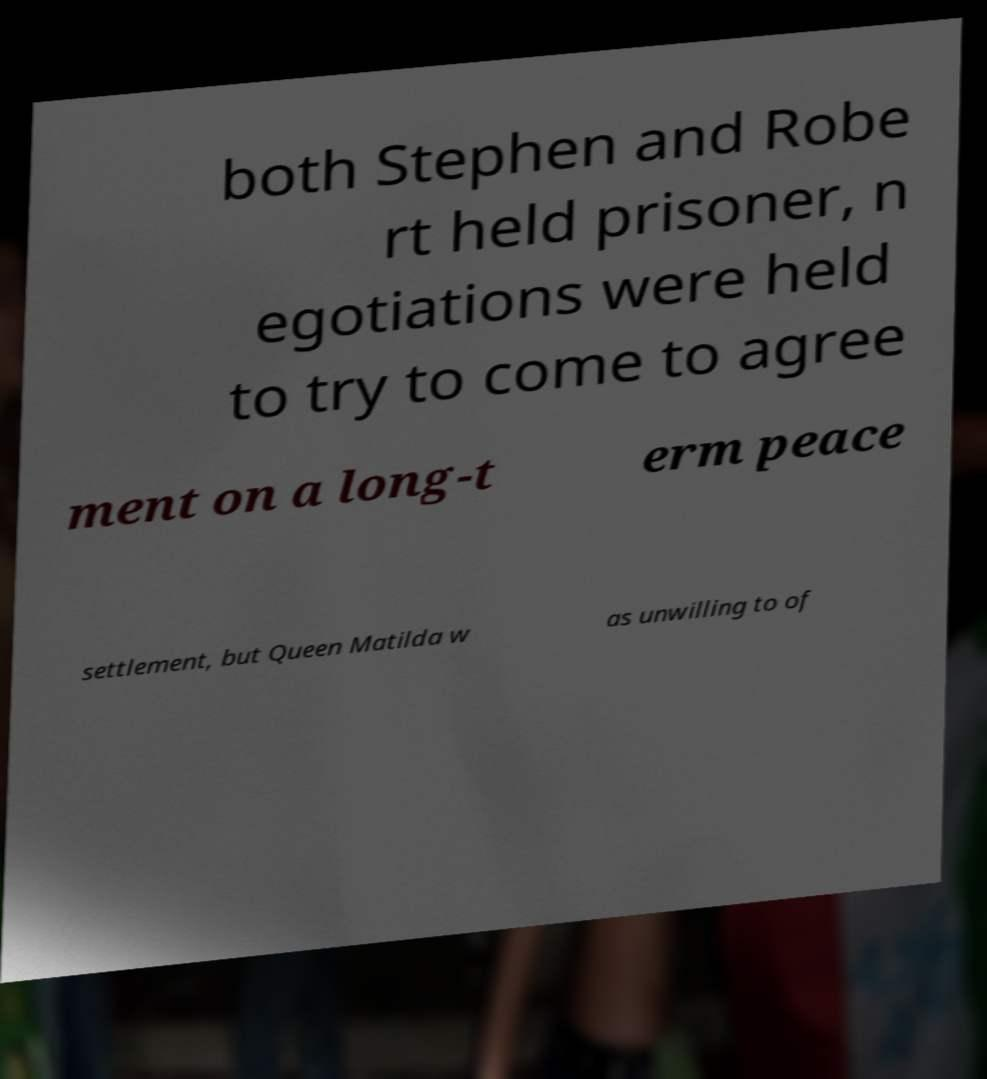What messages or text are displayed in this image? I need them in a readable, typed format. both Stephen and Robe rt held prisoner, n egotiations were held to try to come to agree ment on a long-t erm peace settlement, but Queen Matilda w as unwilling to of 